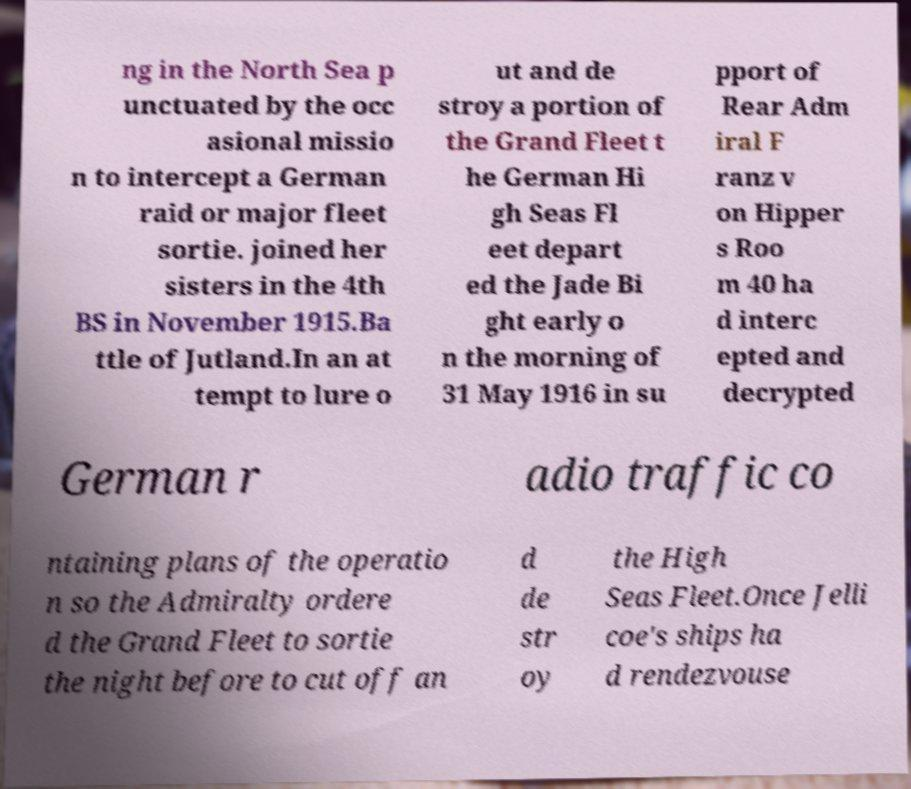For documentation purposes, I need the text within this image transcribed. Could you provide that? ng in the North Sea p unctuated by the occ asional missio n to intercept a German raid or major fleet sortie. joined her sisters in the 4th BS in November 1915.Ba ttle of Jutland.In an at tempt to lure o ut and de stroy a portion of the Grand Fleet t he German Hi gh Seas Fl eet depart ed the Jade Bi ght early o n the morning of 31 May 1916 in su pport of Rear Adm iral F ranz v on Hipper s Roo m 40 ha d interc epted and decrypted German r adio traffic co ntaining plans of the operatio n so the Admiralty ordere d the Grand Fleet to sortie the night before to cut off an d de str oy the High Seas Fleet.Once Jelli coe's ships ha d rendezvouse 